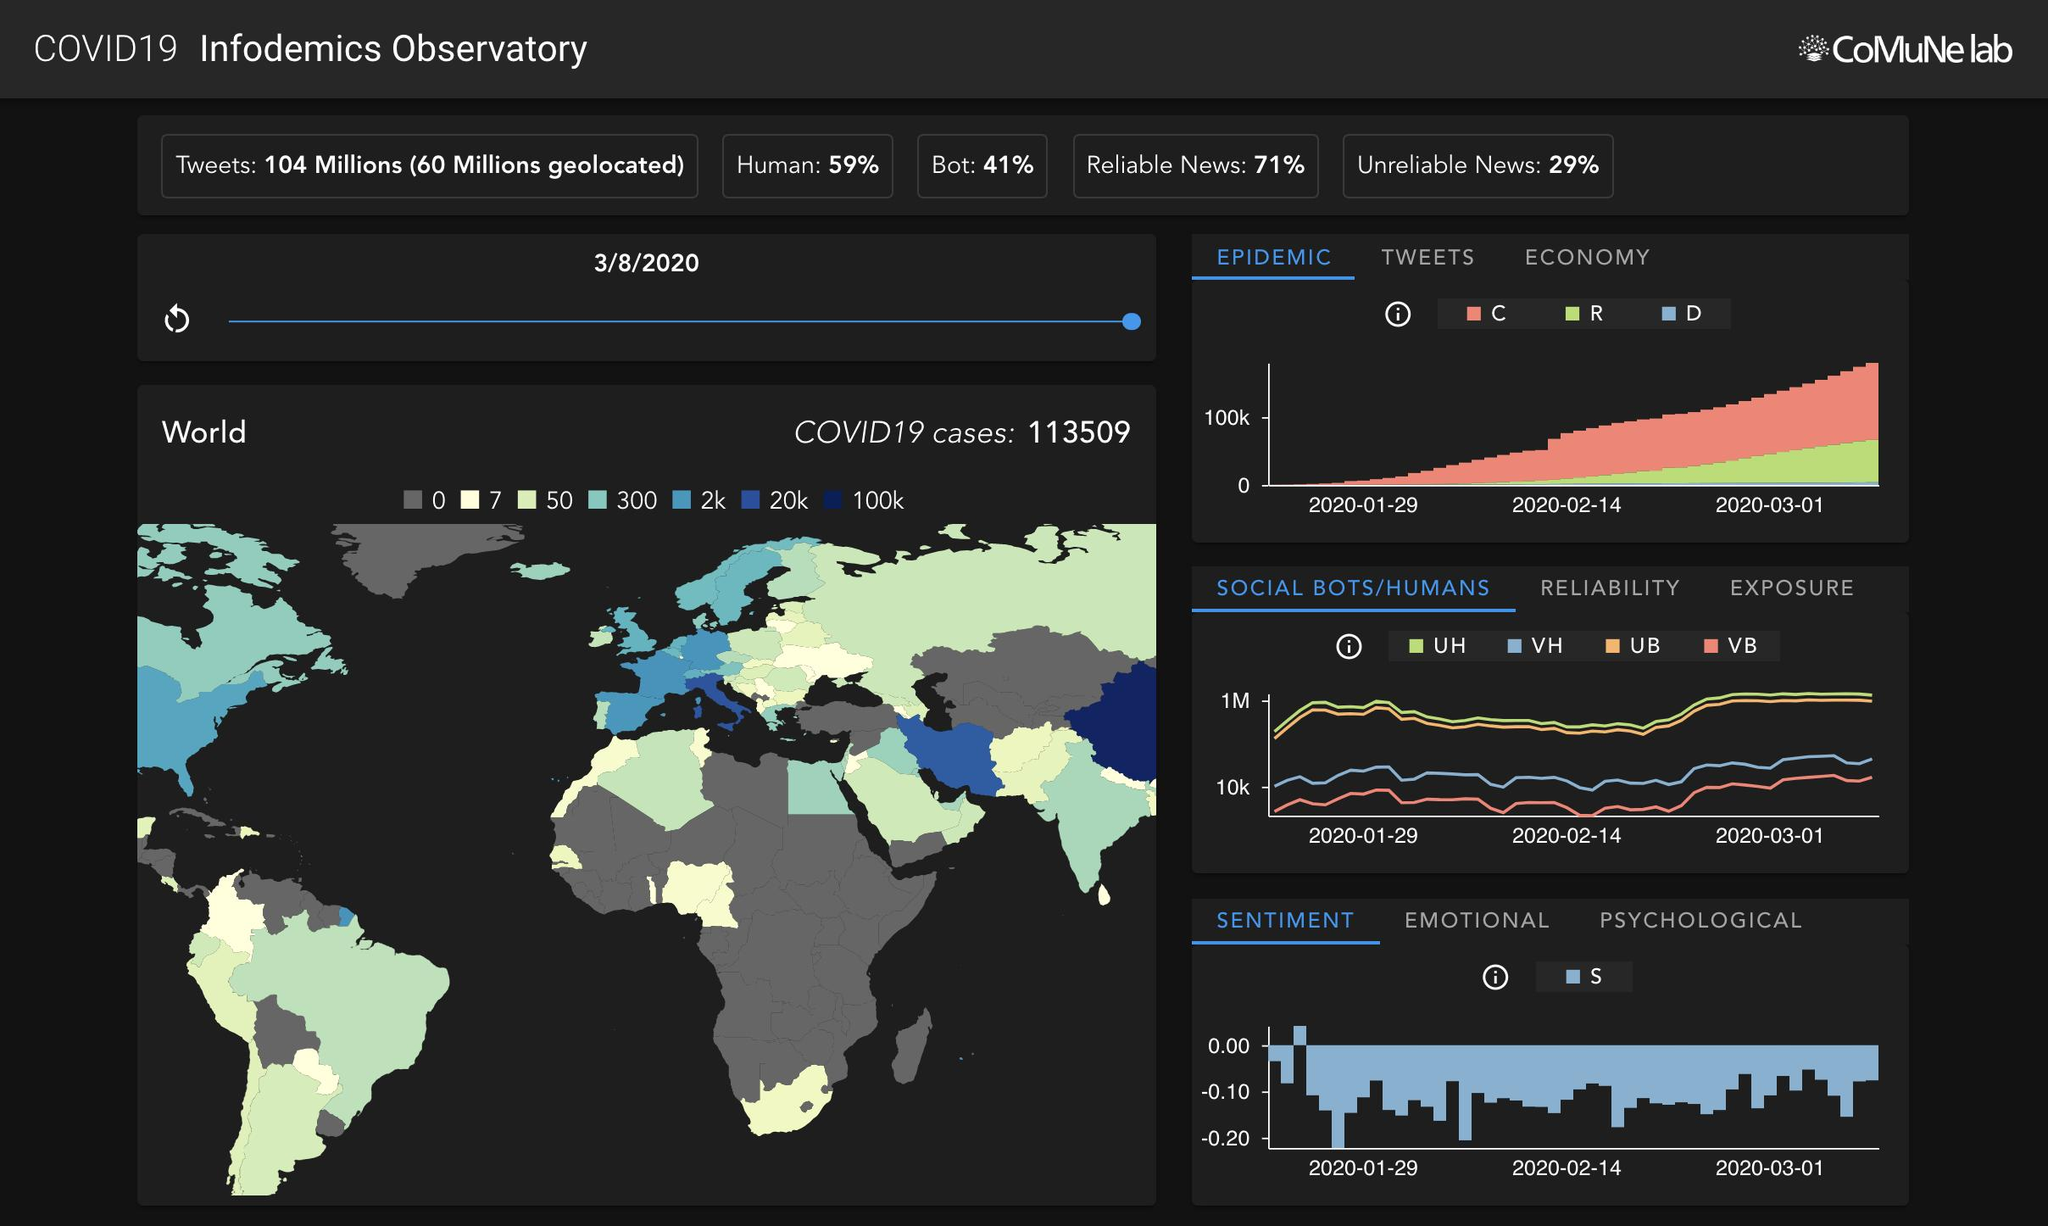Specify some key components in this picture. China has surpassed the 100,000 mark in terms of its population, while India remains the second most populous country in the world. The majority of Africa has zero cases, while Asia has some cases. 